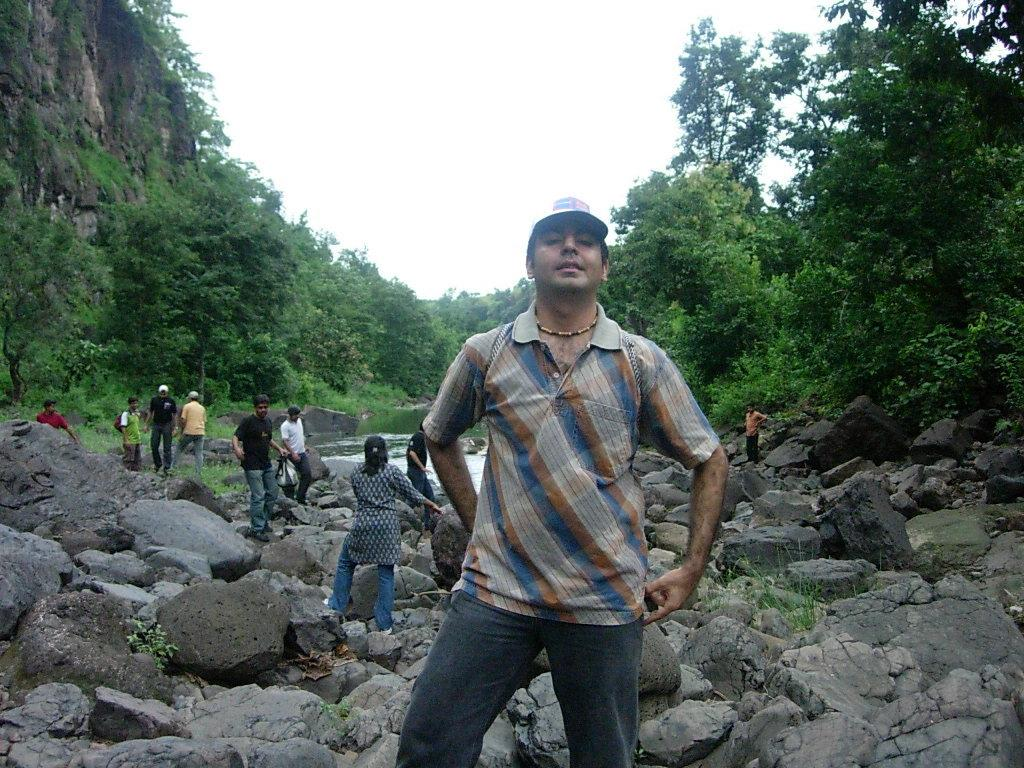Who or what can be seen in the image? There are people in the image. What type of natural features are present in the image? There are rocks, plants, trees, water, and a hill visible in the image. What is visible in the background of the image? The sky is visible in the background of the image. How many stars can be seen in the image? There are no stars visible in the image. What emotions are the people in the image feeling? The image does not provide information about the emotions of the people; we can only see their physical appearance. 